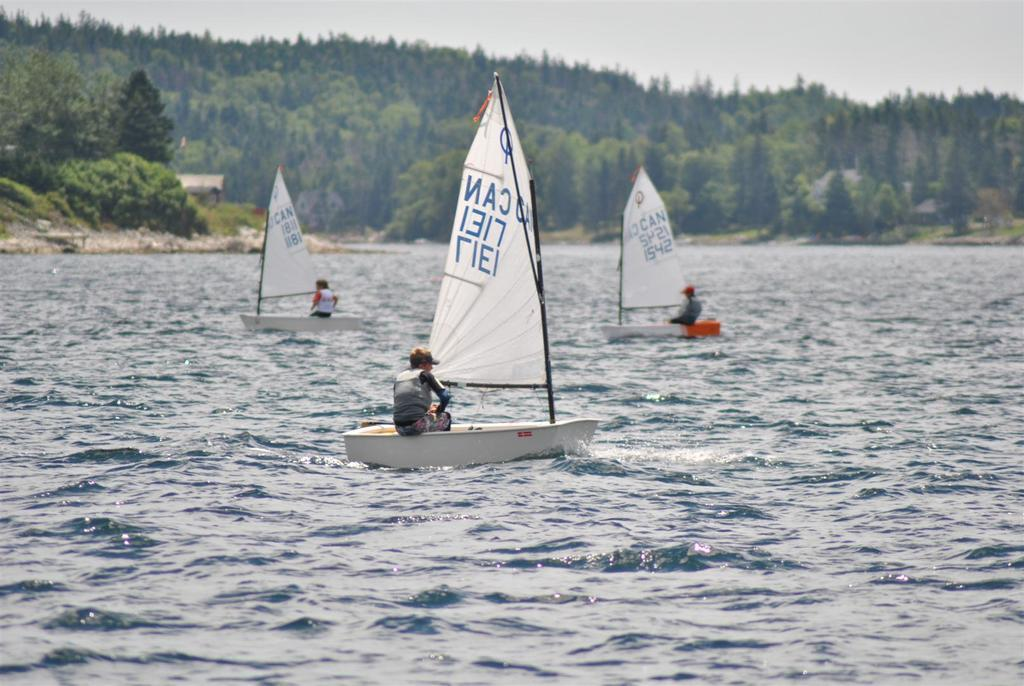What is at the bottom of the image? There is water at the bottom of the image. What are the three persons doing in the image? They are riding boats above the water. What can be seen behind the boats? There are trees behind the boats. What is visible behind the trees? There are hills behind the trees. What is visible at the top of the image? The sky is visible at the top of the image. What degree of fiction is present in the image? The image is not a work of fiction; it is a photograph. Can you tell me how many waterfalls are visible in the image? There is no waterfall present in the image. 